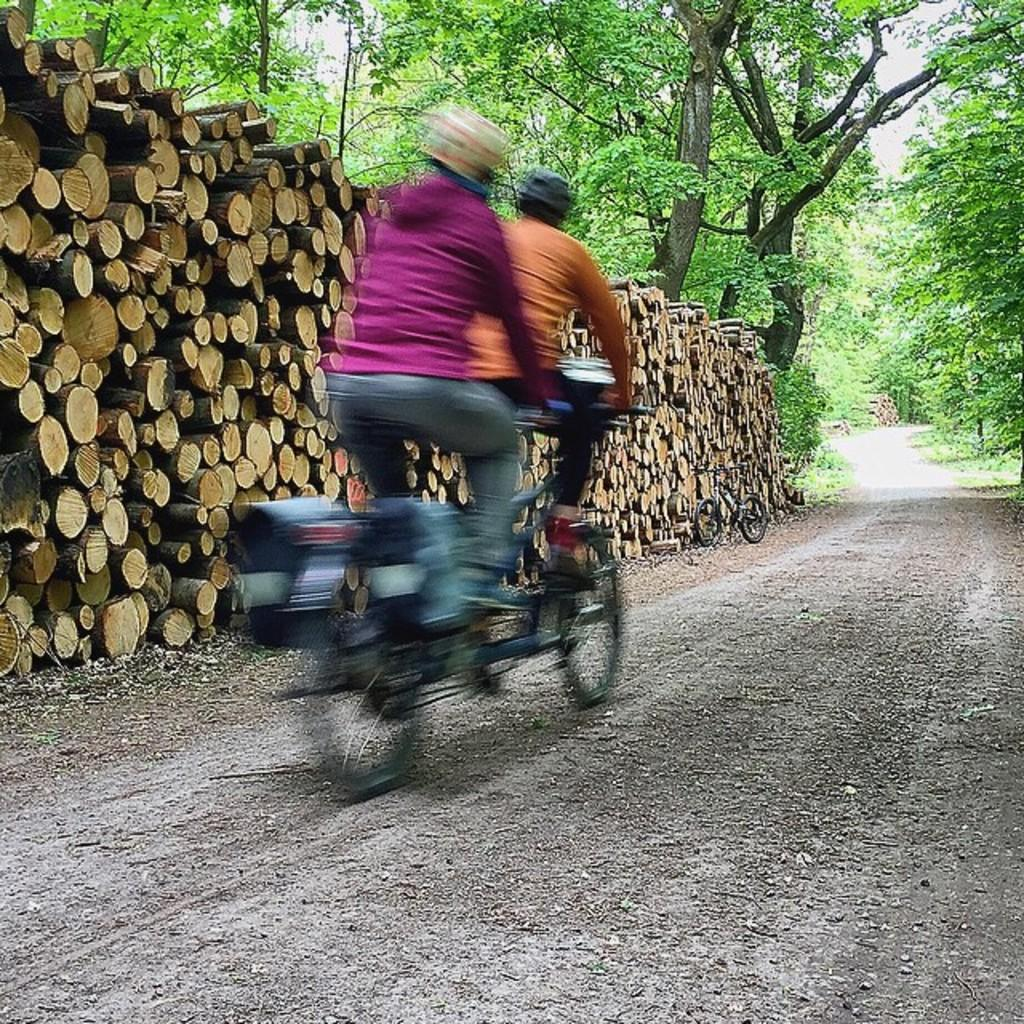How many people are riding the bicycle in the image? There are two people riding the bicycle in the image. What can be seen in the background of the image? Trees are visible in the image. What else is present in the image besides the bicycle and people? There are wooden logs in the image. Where is the bicycle located in the image? The bicycle is on the road in the image. What type of chair is being used to transport the eggs in the image? There is no chair or eggs present in the image; it features two people riding a bicycle on the road with trees and wooden logs in the background. 